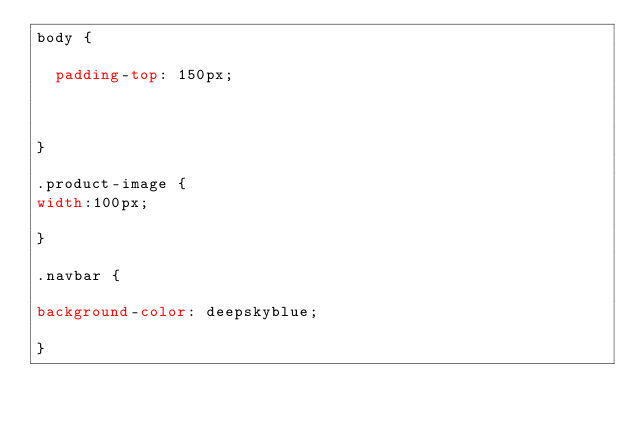<code> <loc_0><loc_0><loc_500><loc_500><_CSS_>body {

  padding-top: 150px;



}

.product-image {
width:100px;

}

.navbar {

background-color: deepskyblue;

}
</code> 